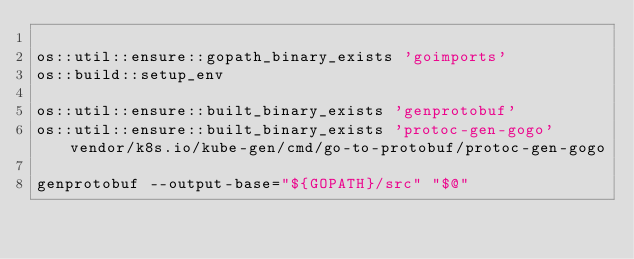Convert code to text. <code><loc_0><loc_0><loc_500><loc_500><_Bash_>
os::util::ensure::gopath_binary_exists 'goimports'
os::build::setup_env

os::util::ensure::built_binary_exists 'genprotobuf'
os::util::ensure::built_binary_exists 'protoc-gen-gogo' vendor/k8s.io/kube-gen/cmd/go-to-protobuf/protoc-gen-gogo

genprotobuf --output-base="${GOPATH}/src" "$@"
</code> 